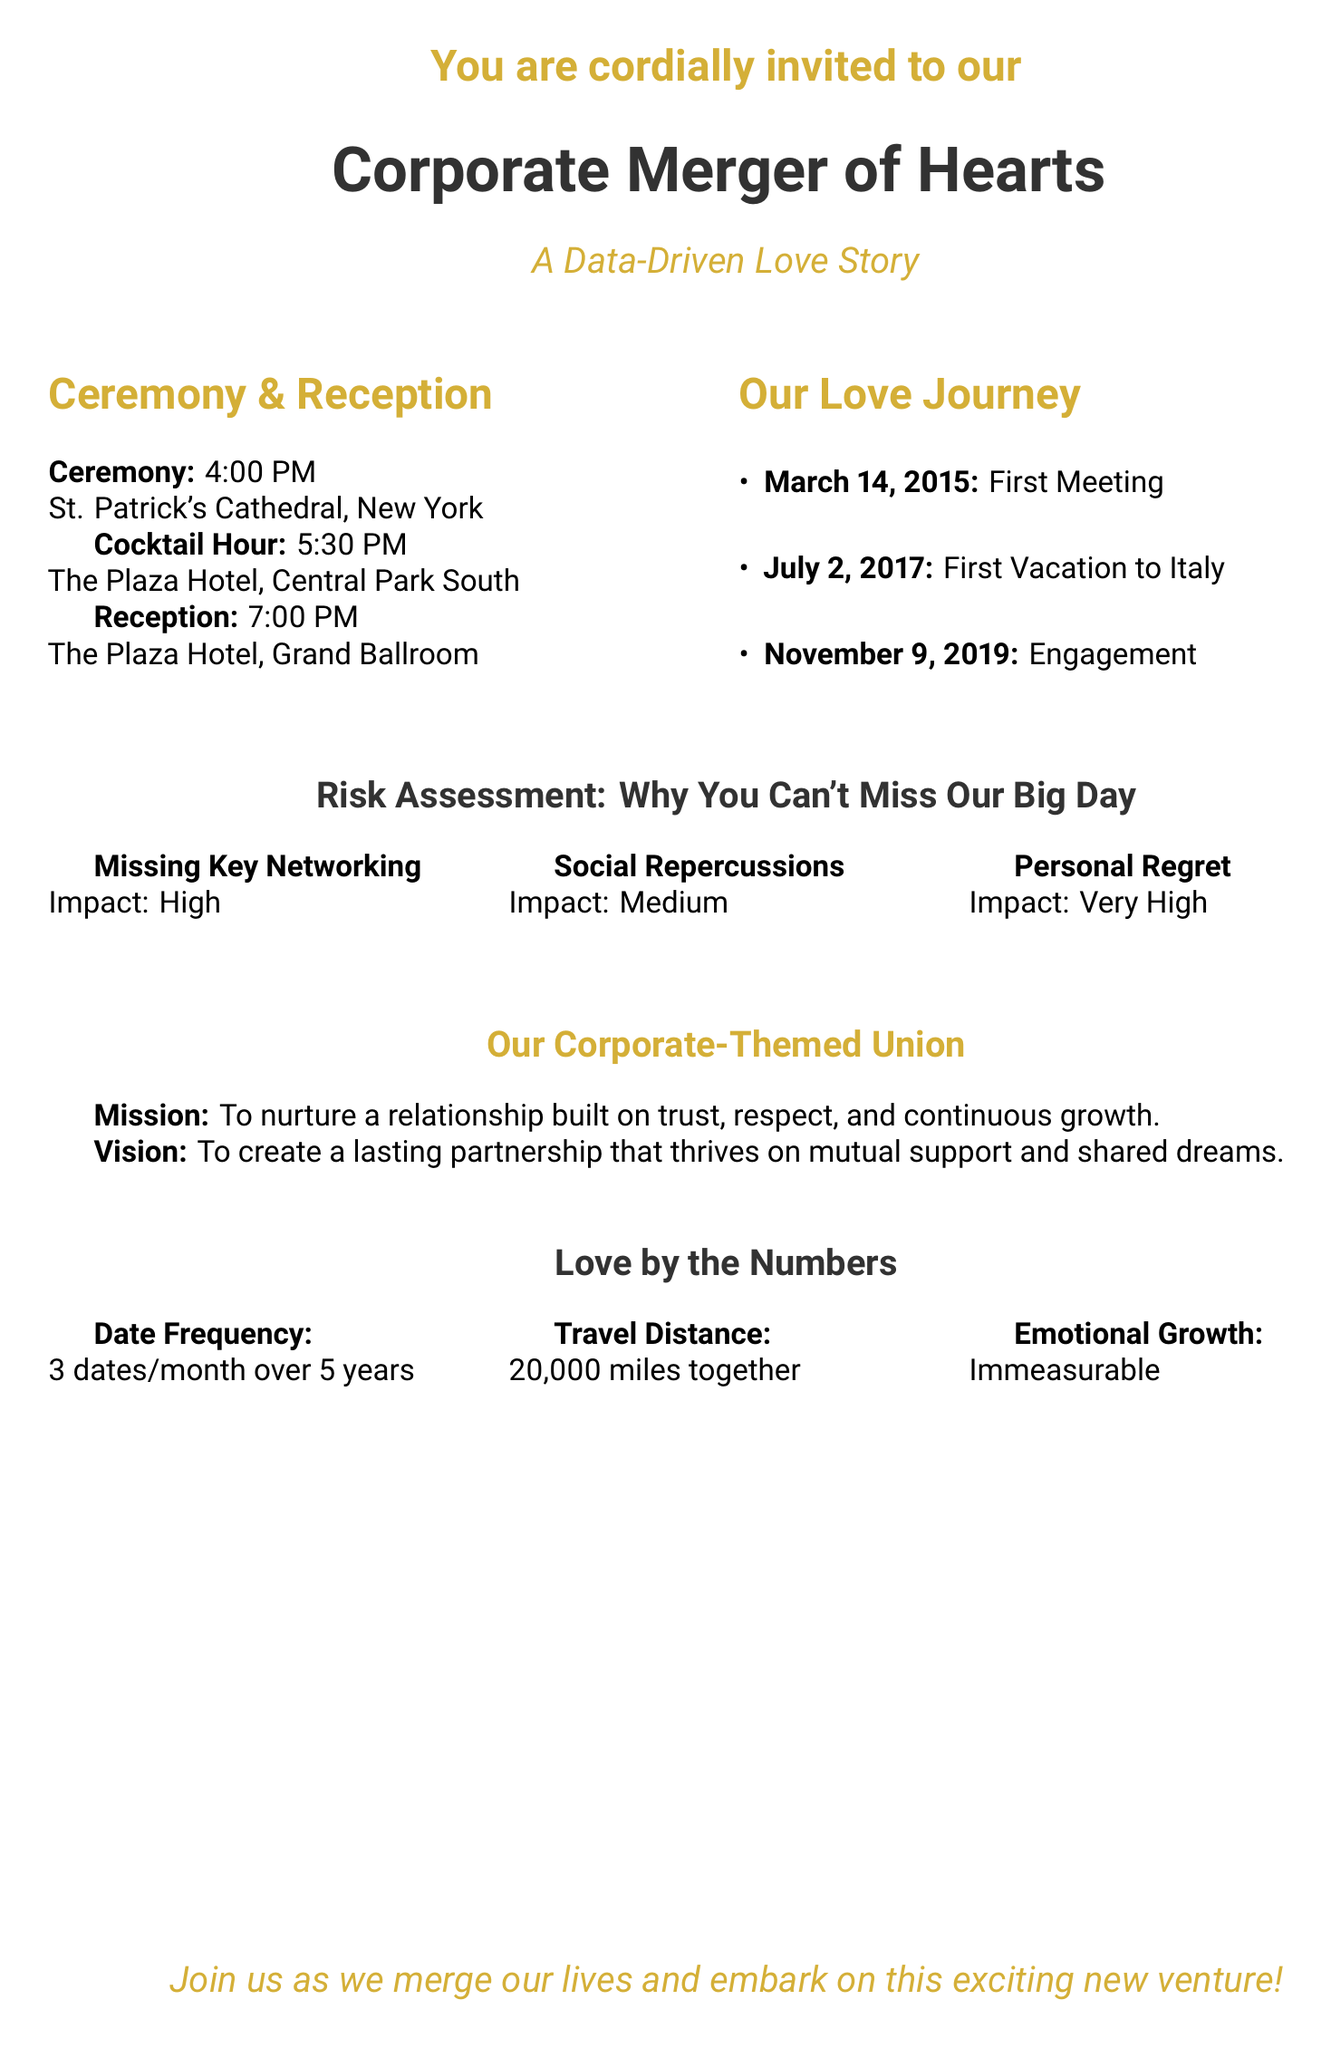What time is the ceremony? The time for the ceremony is explicitly stated in the document as 4:00 PM.
Answer: 4:00 PM Where will the reception be held? The reception location is detailed in the document as The Plaza Hotel, Grand Ballroom.
Answer: The Plaza Hotel, Grand Ballroom What was the first milestone in the couple's relationship? The first milestone is listed as the first meeting on March 14, 2015.
Answer: First Meeting What is the impact of missing personal regret? The document assigns a "Very High" impact level to personal regret.
Answer: Very High What is the mission of the corporate-themed union? The mission is described as nurturing a relationship built on trust, respect, and continuous growth.
Answer: To nurture a relationship built on trust, respect, and continuous growth How many dates did the couple go on each month? The document states that the couple had 3 dates per month.
Answer: 3 dates/month What is the total travel distance covered together by the couple? The travel distance is specified in the document as 20,000 miles together.
Answer: 20,000 miles What is the vision of the couple's union? The vision describes creating a lasting partnership that thrives on mutual support and shared dreams.
Answer: To create a lasting partnership that thrives on mutual support and shared dreams What are the two locations mentioned for the cocktail hour? The cocktail hour location is The Plaza Hotel, Central Park South.
Answer: The Plaza Hotel, Central Park South 